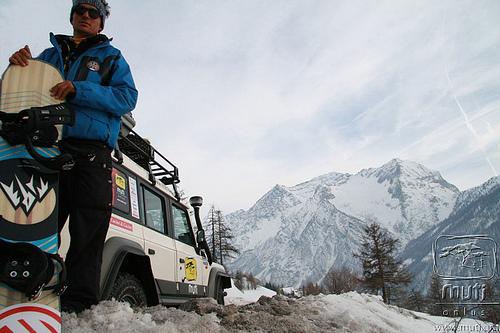What sport is the man going to participate in?
Quick response, please. Snowboarding. What are the tall things called?
Quick response, please. Mountains. What are these people doing?
Answer briefly. Snowboarding. Is there snow on the mountain?
Short answer required. Yes. Is the sky cloudy?
Write a very short answer. Yes. 